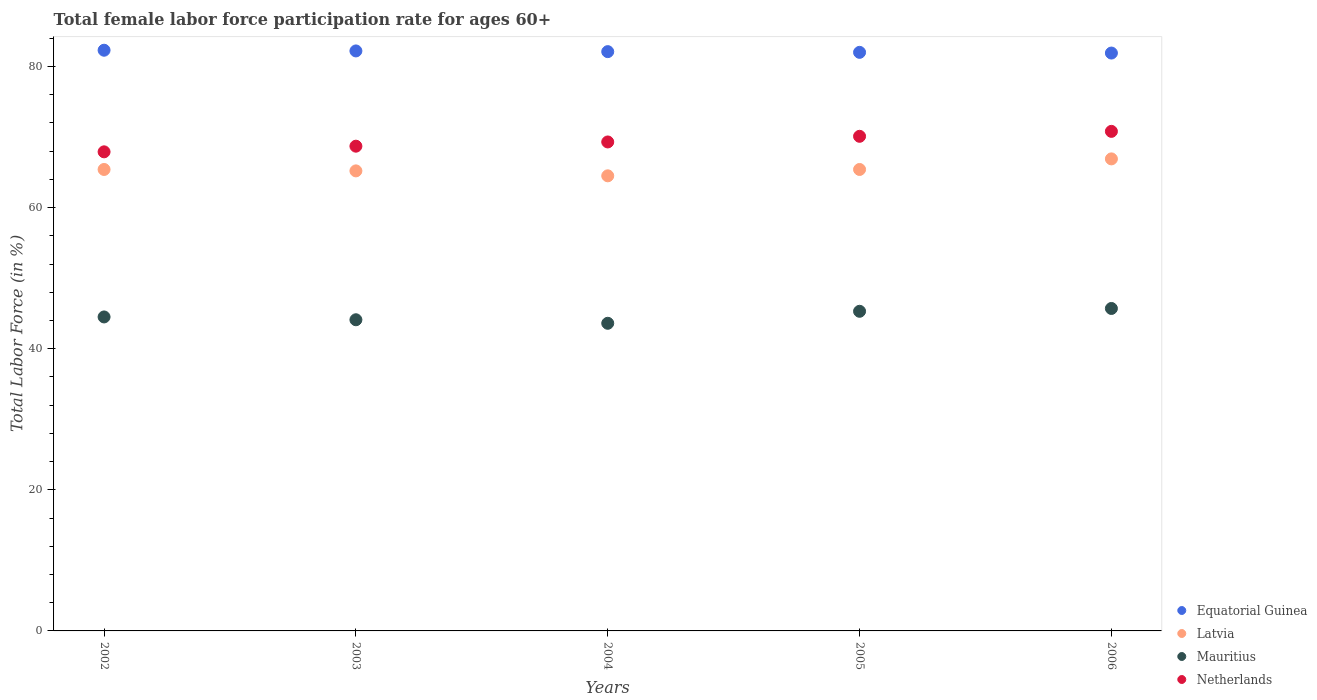How many different coloured dotlines are there?
Offer a terse response. 4. Is the number of dotlines equal to the number of legend labels?
Make the answer very short. Yes. What is the female labor force participation rate in Equatorial Guinea in 2003?
Offer a very short reply. 82.2. Across all years, what is the maximum female labor force participation rate in Netherlands?
Give a very brief answer. 70.8. Across all years, what is the minimum female labor force participation rate in Latvia?
Your response must be concise. 64.5. In which year was the female labor force participation rate in Netherlands maximum?
Keep it short and to the point. 2006. In which year was the female labor force participation rate in Mauritius minimum?
Offer a very short reply. 2004. What is the total female labor force participation rate in Equatorial Guinea in the graph?
Offer a very short reply. 410.5. What is the difference between the female labor force participation rate in Mauritius in 2003 and that in 2006?
Give a very brief answer. -1.6. What is the difference between the female labor force participation rate in Equatorial Guinea in 2003 and the female labor force participation rate in Latvia in 2005?
Your answer should be very brief. 16.8. What is the average female labor force participation rate in Latvia per year?
Offer a very short reply. 65.48. In the year 2003, what is the difference between the female labor force participation rate in Netherlands and female labor force participation rate in Equatorial Guinea?
Make the answer very short. -13.5. What is the ratio of the female labor force participation rate in Netherlands in 2004 to that in 2006?
Ensure brevity in your answer.  0.98. Is the female labor force participation rate in Netherlands in 2002 less than that in 2006?
Your answer should be compact. Yes. What is the difference between the highest and the second highest female labor force participation rate in Equatorial Guinea?
Provide a succinct answer. 0.1. What is the difference between the highest and the lowest female labor force participation rate in Netherlands?
Make the answer very short. 2.9. Is the sum of the female labor force participation rate in Latvia in 2002 and 2004 greater than the maximum female labor force participation rate in Equatorial Guinea across all years?
Your answer should be very brief. Yes. Is it the case that in every year, the sum of the female labor force participation rate in Netherlands and female labor force participation rate in Equatorial Guinea  is greater than the sum of female labor force participation rate in Mauritius and female labor force participation rate in Latvia?
Provide a succinct answer. No. Does the female labor force participation rate in Latvia monotonically increase over the years?
Provide a succinct answer. No. Is the female labor force participation rate in Netherlands strictly greater than the female labor force participation rate in Equatorial Guinea over the years?
Your response must be concise. No. How many years are there in the graph?
Give a very brief answer. 5. Are the values on the major ticks of Y-axis written in scientific E-notation?
Provide a short and direct response. No. Does the graph contain any zero values?
Keep it short and to the point. No. Where does the legend appear in the graph?
Your answer should be compact. Bottom right. What is the title of the graph?
Provide a succinct answer. Total female labor force participation rate for ages 60+. Does "World" appear as one of the legend labels in the graph?
Your answer should be very brief. No. What is the label or title of the Y-axis?
Ensure brevity in your answer.  Total Labor Force (in %). What is the Total Labor Force (in %) in Equatorial Guinea in 2002?
Give a very brief answer. 82.3. What is the Total Labor Force (in %) of Latvia in 2002?
Your response must be concise. 65.4. What is the Total Labor Force (in %) in Mauritius in 2002?
Offer a very short reply. 44.5. What is the Total Labor Force (in %) in Netherlands in 2002?
Ensure brevity in your answer.  67.9. What is the Total Labor Force (in %) in Equatorial Guinea in 2003?
Provide a short and direct response. 82.2. What is the Total Labor Force (in %) of Latvia in 2003?
Ensure brevity in your answer.  65.2. What is the Total Labor Force (in %) of Mauritius in 2003?
Keep it short and to the point. 44.1. What is the Total Labor Force (in %) in Netherlands in 2003?
Offer a terse response. 68.7. What is the Total Labor Force (in %) in Equatorial Guinea in 2004?
Provide a succinct answer. 82.1. What is the Total Labor Force (in %) of Latvia in 2004?
Ensure brevity in your answer.  64.5. What is the Total Labor Force (in %) of Mauritius in 2004?
Provide a succinct answer. 43.6. What is the Total Labor Force (in %) of Netherlands in 2004?
Give a very brief answer. 69.3. What is the Total Labor Force (in %) of Latvia in 2005?
Give a very brief answer. 65.4. What is the Total Labor Force (in %) of Mauritius in 2005?
Ensure brevity in your answer.  45.3. What is the Total Labor Force (in %) of Netherlands in 2005?
Provide a succinct answer. 70.1. What is the Total Labor Force (in %) in Equatorial Guinea in 2006?
Your answer should be compact. 81.9. What is the Total Labor Force (in %) in Latvia in 2006?
Offer a very short reply. 66.9. What is the Total Labor Force (in %) in Mauritius in 2006?
Offer a very short reply. 45.7. What is the Total Labor Force (in %) in Netherlands in 2006?
Make the answer very short. 70.8. Across all years, what is the maximum Total Labor Force (in %) of Equatorial Guinea?
Your answer should be very brief. 82.3. Across all years, what is the maximum Total Labor Force (in %) of Latvia?
Give a very brief answer. 66.9. Across all years, what is the maximum Total Labor Force (in %) in Mauritius?
Give a very brief answer. 45.7. Across all years, what is the maximum Total Labor Force (in %) in Netherlands?
Offer a very short reply. 70.8. Across all years, what is the minimum Total Labor Force (in %) of Equatorial Guinea?
Keep it short and to the point. 81.9. Across all years, what is the minimum Total Labor Force (in %) in Latvia?
Your response must be concise. 64.5. Across all years, what is the minimum Total Labor Force (in %) in Mauritius?
Provide a succinct answer. 43.6. Across all years, what is the minimum Total Labor Force (in %) of Netherlands?
Offer a very short reply. 67.9. What is the total Total Labor Force (in %) in Equatorial Guinea in the graph?
Your response must be concise. 410.5. What is the total Total Labor Force (in %) in Latvia in the graph?
Keep it short and to the point. 327.4. What is the total Total Labor Force (in %) of Mauritius in the graph?
Your response must be concise. 223.2. What is the total Total Labor Force (in %) in Netherlands in the graph?
Offer a very short reply. 346.8. What is the difference between the Total Labor Force (in %) of Latvia in 2002 and that in 2003?
Your answer should be compact. 0.2. What is the difference between the Total Labor Force (in %) of Mauritius in 2002 and that in 2003?
Ensure brevity in your answer.  0.4. What is the difference between the Total Labor Force (in %) of Netherlands in 2002 and that in 2003?
Make the answer very short. -0.8. What is the difference between the Total Labor Force (in %) of Equatorial Guinea in 2002 and that in 2004?
Provide a succinct answer. 0.2. What is the difference between the Total Labor Force (in %) in Latvia in 2002 and that in 2004?
Make the answer very short. 0.9. What is the difference between the Total Labor Force (in %) in Netherlands in 2002 and that in 2004?
Ensure brevity in your answer.  -1.4. What is the difference between the Total Labor Force (in %) of Equatorial Guinea in 2002 and that in 2005?
Provide a short and direct response. 0.3. What is the difference between the Total Labor Force (in %) of Latvia in 2002 and that in 2005?
Make the answer very short. 0. What is the difference between the Total Labor Force (in %) of Netherlands in 2002 and that in 2005?
Offer a terse response. -2.2. What is the difference between the Total Labor Force (in %) of Netherlands in 2002 and that in 2006?
Keep it short and to the point. -2.9. What is the difference between the Total Labor Force (in %) of Latvia in 2003 and that in 2004?
Provide a short and direct response. 0.7. What is the difference between the Total Labor Force (in %) of Mauritius in 2003 and that in 2004?
Give a very brief answer. 0.5. What is the difference between the Total Labor Force (in %) of Netherlands in 2003 and that in 2004?
Provide a succinct answer. -0.6. What is the difference between the Total Labor Force (in %) of Equatorial Guinea in 2003 and that in 2006?
Your answer should be very brief. 0.3. What is the difference between the Total Labor Force (in %) in Mauritius in 2003 and that in 2006?
Make the answer very short. -1.6. What is the difference between the Total Labor Force (in %) in Netherlands in 2003 and that in 2006?
Keep it short and to the point. -2.1. What is the difference between the Total Labor Force (in %) in Latvia in 2004 and that in 2005?
Make the answer very short. -0.9. What is the difference between the Total Labor Force (in %) in Netherlands in 2004 and that in 2005?
Offer a terse response. -0.8. What is the difference between the Total Labor Force (in %) in Equatorial Guinea in 2004 and that in 2006?
Your answer should be compact. 0.2. What is the difference between the Total Labor Force (in %) in Mauritius in 2004 and that in 2006?
Ensure brevity in your answer.  -2.1. What is the difference between the Total Labor Force (in %) in Equatorial Guinea in 2005 and that in 2006?
Provide a short and direct response. 0.1. What is the difference between the Total Labor Force (in %) in Mauritius in 2005 and that in 2006?
Give a very brief answer. -0.4. What is the difference between the Total Labor Force (in %) in Netherlands in 2005 and that in 2006?
Provide a short and direct response. -0.7. What is the difference between the Total Labor Force (in %) in Equatorial Guinea in 2002 and the Total Labor Force (in %) in Latvia in 2003?
Provide a short and direct response. 17.1. What is the difference between the Total Labor Force (in %) of Equatorial Guinea in 2002 and the Total Labor Force (in %) of Mauritius in 2003?
Give a very brief answer. 38.2. What is the difference between the Total Labor Force (in %) in Equatorial Guinea in 2002 and the Total Labor Force (in %) in Netherlands in 2003?
Offer a very short reply. 13.6. What is the difference between the Total Labor Force (in %) of Latvia in 2002 and the Total Labor Force (in %) of Mauritius in 2003?
Ensure brevity in your answer.  21.3. What is the difference between the Total Labor Force (in %) of Latvia in 2002 and the Total Labor Force (in %) of Netherlands in 2003?
Offer a very short reply. -3.3. What is the difference between the Total Labor Force (in %) in Mauritius in 2002 and the Total Labor Force (in %) in Netherlands in 2003?
Your response must be concise. -24.2. What is the difference between the Total Labor Force (in %) of Equatorial Guinea in 2002 and the Total Labor Force (in %) of Latvia in 2004?
Offer a very short reply. 17.8. What is the difference between the Total Labor Force (in %) of Equatorial Guinea in 2002 and the Total Labor Force (in %) of Mauritius in 2004?
Give a very brief answer. 38.7. What is the difference between the Total Labor Force (in %) in Equatorial Guinea in 2002 and the Total Labor Force (in %) in Netherlands in 2004?
Your response must be concise. 13. What is the difference between the Total Labor Force (in %) in Latvia in 2002 and the Total Labor Force (in %) in Mauritius in 2004?
Your answer should be very brief. 21.8. What is the difference between the Total Labor Force (in %) in Mauritius in 2002 and the Total Labor Force (in %) in Netherlands in 2004?
Make the answer very short. -24.8. What is the difference between the Total Labor Force (in %) in Equatorial Guinea in 2002 and the Total Labor Force (in %) in Latvia in 2005?
Provide a succinct answer. 16.9. What is the difference between the Total Labor Force (in %) in Equatorial Guinea in 2002 and the Total Labor Force (in %) in Mauritius in 2005?
Provide a succinct answer. 37. What is the difference between the Total Labor Force (in %) of Equatorial Guinea in 2002 and the Total Labor Force (in %) of Netherlands in 2005?
Offer a terse response. 12.2. What is the difference between the Total Labor Force (in %) of Latvia in 2002 and the Total Labor Force (in %) of Mauritius in 2005?
Your response must be concise. 20.1. What is the difference between the Total Labor Force (in %) of Mauritius in 2002 and the Total Labor Force (in %) of Netherlands in 2005?
Make the answer very short. -25.6. What is the difference between the Total Labor Force (in %) in Equatorial Guinea in 2002 and the Total Labor Force (in %) in Latvia in 2006?
Make the answer very short. 15.4. What is the difference between the Total Labor Force (in %) of Equatorial Guinea in 2002 and the Total Labor Force (in %) of Mauritius in 2006?
Your answer should be compact. 36.6. What is the difference between the Total Labor Force (in %) of Equatorial Guinea in 2002 and the Total Labor Force (in %) of Netherlands in 2006?
Make the answer very short. 11.5. What is the difference between the Total Labor Force (in %) in Latvia in 2002 and the Total Labor Force (in %) in Mauritius in 2006?
Offer a terse response. 19.7. What is the difference between the Total Labor Force (in %) of Latvia in 2002 and the Total Labor Force (in %) of Netherlands in 2006?
Offer a very short reply. -5.4. What is the difference between the Total Labor Force (in %) in Mauritius in 2002 and the Total Labor Force (in %) in Netherlands in 2006?
Make the answer very short. -26.3. What is the difference between the Total Labor Force (in %) in Equatorial Guinea in 2003 and the Total Labor Force (in %) in Latvia in 2004?
Ensure brevity in your answer.  17.7. What is the difference between the Total Labor Force (in %) in Equatorial Guinea in 2003 and the Total Labor Force (in %) in Mauritius in 2004?
Make the answer very short. 38.6. What is the difference between the Total Labor Force (in %) in Equatorial Guinea in 2003 and the Total Labor Force (in %) in Netherlands in 2004?
Make the answer very short. 12.9. What is the difference between the Total Labor Force (in %) in Latvia in 2003 and the Total Labor Force (in %) in Mauritius in 2004?
Provide a succinct answer. 21.6. What is the difference between the Total Labor Force (in %) in Latvia in 2003 and the Total Labor Force (in %) in Netherlands in 2004?
Keep it short and to the point. -4.1. What is the difference between the Total Labor Force (in %) in Mauritius in 2003 and the Total Labor Force (in %) in Netherlands in 2004?
Your response must be concise. -25.2. What is the difference between the Total Labor Force (in %) of Equatorial Guinea in 2003 and the Total Labor Force (in %) of Latvia in 2005?
Provide a succinct answer. 16.8. What is the difference between the Total Labor Force (in %) in Equatorial Guinea in 2003 and the Total Labor Force (in %) in Mauritius in 2005?
Keep it short and to the point. 36.9. What is the difference between the Total Labor Force (in %) of Equatorial Guinea in 2003 and the Total Labor Force (in %) of Netherlands in 2005?
Your answer should be very brief. 12.1. What is the difference between the Total Labor Force (in %) in Latvia in 2003 and the Total Labor Force (in %) in Mauritius in 2005?
Offer a terse response. 19.9. What is the difference between the Total Labor Force (in %) in Mauritius in 2003 and the Total Labor Force (in %) in Netherlands in 2005?
Make the answer very short. -26. What is the difference between the Total Labor Force (in %) in Equatorial Guinea in 2003 and the Total Labor Force (in %) in Mauritius in 2006?
Provide a succinct answer. 36.5. What is the difference between the Total Labor Force (in %) of Equatorial Guinea in 2003 and the Total Labor Force (in %) of Netherlands in 2006?
Offer a very short reply. 11.4. What is the difference between the Total Labor Force (in %) of Latvia in 2003 and the Total Labor Force (in %) of Mauritius in 2006?
Keep it short and to the point. 19.5. What is the difference between the Total Labor Force (in %) of Latvia in 2003 and the Total Labor Force (in %) of Netherlands in 2006?
Offer a terse response. -5.6. What is the difference between the Total Labor Force (in %) of Mauritius in 2003 and the Total Labor Force (in %) of Netherlands in 2006?
Your response must be concise. -26.7. What is the difference between the Total Labor Force (in %) of Equatorial Guinea in 2004 and the Total Labor Force (in %) of Latvia in 2005?
Keep it short and to the point. 16.7. What is the difference between the Total Labor Force (in %) in Equatorial Guinea in 2004 and the Total Labor Force (in %) in Mauritius in 2005?
Ensure brevity in your answer.  36.8. What is the difference between the Total Labor Force (in %) in Mauritius in 2004 and the Total Labor Force (in %) in Netherlands in 2005?
Your response must be concise. -26.5. What is the difference between the Total Labor Force (in %) in Equatorial Guinea in 2004 and the Total Labor Force (in %) in Latvia in 2006?
Give a very brief answer. 15.2. What is the difference between the Total Labor Force (in %) in Equatorial Guinea in 2004 and the Total Labor Force (in %) in Mauritius in 2006?
Make the answer very short. 36.4. What is the difference between the Total Labor Force (in %) of Latvia in 2004 and the Total Labor Force (in %) of Netherlands in 2006?
Your answer should be very brief. -6.3. What is the difference between the Total Labor Force (in %) of Mauritius in 2004 and the Total Labor Force (in %) of Netherlands in 2006?
Make the answer very short. -27.2. What is the difference between the Total Labor Force (in %) in Equatorial Guinea in 2005 and the Total Labor Force (in %) in Mauritius in 2006?
Offer a terse response. 36.3. What is the difference between the Total Labor Force (in %) of Mauritius in 2005 and the Total Labor Force (in %) of Netherlands in 2006?
Provide a short and direct response. -25.5. What is the average Total Labor Force (in %) in Equatorial Guinea per year?
Give a very brief answer. 82.1. What is the average Total Labor Force (in %) of Latvia per year?
Ensure brevity in your answer.  65.48. What is the average Total Labor Force (in %) in Mauritius per year?
Offer a very short reply. 44.64. What is the average Total Labor Force (in %) in Netherlands per year?
Provide a short and direct response. 69.36. In the year 2002, what is the difference between the Total Labor Force (in %) of Equatorial Guinea and Total Labor Force (in %) of Mauritius?
Your answer should be compact. 37.8. In the year 2002, what is the difference between the Total Labor Force (in %) in Equatorial Guinea and Total Labor Force (in %) in Netherlands?
Make the answer very short. 14.4. In the year 2002, what is the difference between the Total Labor Force (in %) of Latvia and Total Labor Force (in %) of Mauritius?
Your response must be concise. 20.9. In the year 2002, what is the difference between the Total Labor Force (in %) in Mauritius and Total Labor Force (in %) in Netherlands?
Give a very brief answer. -23.4. In the year 2003, what is the difference between the Total Labor Force (in %) in Equatorial Guinea and Total Labor Force (in %) in Latvia?
Offer a very short reply. 17. In the year 2003, what is the difference between the Total Labor Force (in %) of Equatorial Guinea and Total Labor Force (in %) of Mauritius?
Ensure brevity in your answer.  38.1. In the year 2003, what is the difference between the Total Labor Force (in %) in Equatorial Guinea and Total Labor Force (in %) in Netherlands?
Ensure brevity in your answer.  13.5. In the year 2003, what is the difference between the Total Labor Force (in %) of Latvia and Total Labor Force (in %) of Mauritius?
Offer a terse response. 21.1. In the year 2003, what is the difference between the Total Labor Force (in %) of Mauritius and Total Labor Force (in %) of Netherlands?
Ensure brevity in your answer.  -24.6. In the year 2004, what is the difference between the Total Labor Force (in %) in Equatorial Guinea and Total Labor Force (in %) in Mauritius?
Provide a short and direct response. 38.5. In the year 2004, what is the difference between the Total Labor Force (in %) in Equatorial Guinea and Total Labor Force (in %) in Netherlands?
Give a very brief answer. 12.8. In the year 2004, what is the difference between the Total Labor Force (in %) in Latvia and Total Labor Force (in %) in Mauritius?
Ensure brevity in your answer.  20.9. In the year 2004, what is the difference between the Total Labor Force (in %) of Mauritius and Total Labor Force (in %) of Netherlands?
Ensure brevity in your answer.  -25.7. In the year 2005, what is the difference between the Total Labor Force (in %) of Equatorial Guinea and Total Labor Force (in %) of Mauritius?
Your answer should be compact. 36.7. In the year 2005, what is the difference between the Total Labor Force (in %) in Equatorial Guinea and Total Labor Force (in %) in Netherlands?
Keep it short and to the point. 11.9. In the year 2005, what is the difference between the Total Labor Force (in %) in Latvia and Total Labor Force (in %) in Mauritius?
Make the answer very short. 20.1. In the year 2005, what is the difference between the Total Labor Force (in %) in Latvia and Total Labor Force (in %) in Netherlands?
Keep it short and to the point. -4.7. In the year 2005, what is the difference between the Total Labor Force (in %) in Mauritius and Total Labor Force (in %) in Netherlands?
Make the answer very short. -24.8. In the year 2006, what is the difference between the Total Labor Force (in %) in Equatorial Guinea and Total Labor Force (in %) in Mauritius?
Your answer should be compact. 36.2. In the year 2006, what is the difference between the Total Labor Force (in %) in Latvia and Total Labor Force (in %) in Mauritius?
Provide a succinct answer. 21.2. In the year 2006, what is the difference between the Total Labor Force (in %) of Latvia and Total Labor Force (in %) of Netherlands?
Offer a terse response. -3.9. In the year 2006, what is the difference between the Total Labor Force (in %) in Mauritius and Total Labor Force (in %) in Netherlands?
Make the answer very short. -25.1. What is the ratio of the Total Labor Force (in %) of Latvia in 2002 to that in 2003?
Your response must be concise. 1. What is the ratio of the Total Labor Force (in %) of Mauritius in 2002 to that in 2003?
Ensure brevity in your answer.  1.01. What is the ratio of the Total Labor Force (in %) in Netherlands in 2002 to that in 2003?
Your answer should be very brief. 0.99. What is the ratio of the Total Labor Force (in %) in Mauritius in 2002 to that in 2004?
Offer a terse response. 1.02. What is the ratio of the Total Labor Force (in %) of Netherlands in 2002 to that in 2004?
Your answer should be compact. 0.98. What is the ratio of the Total Labor Force (in %) of Equatorial Guinea in 2002 to that in 2005?
Your response must be concise. 1. What is the ratio of the Total Labor Force (in %) of Latvia in 2002 to that in 2005?
Make the answer very short. 1. What is the ratio of the Total Labor Force (in %) in Mauritius in 2002 to that in 2005?
Offer a terse response. 0.98. What is the ratio of the Total Labor Force (in %) of Netherlands in 2002 to that in 2005?
Your answer should be compact. 0.97. What is the ratio of the Total Labor Force (in %) of Equatorial Guinea in 2002 to that in 2006?
Keep it short and to the point. 1. What is the ratio of the Total Labor Force (in %) in Latvia in 2002 to that in 2006?
Make the answer very short. 0.98. What is the ratio of the Total Labor Force (in %) of Mauritius in 2002 to that in 2006?
Offer a very short reply. 0.97. What is the ratio of the Total Labor Force (in %) in Netherlands in 2002 to that in 2006?
Your answer should be very brief. 0.96. What is the ratio of the Total Labor Force (in %) in Equatorial Guinea in 2003 to that in 2004?
Give a very brief answer. 1. What is the ratio of the Total Labor Force (in %) of Latvia in 2003 to that in 2004?
Make the answer very short. 1.01. What is the ratio of the Total Labor Force (in %) of Mauritius in 2003 to that in 2004?
Your answer should be very brief. 1.01. What is the ratio of the Total Labor Force (in %) in Equatorial Guinea in 2003 to that in 2005?
Your answer should be very brief. 1. What is the ratio of the Total Labor Force (in %) in Mauritius in 2003 to that in 2005?
Provide a short and direct response. 0.97. What is the ratio of the Total Labor Force (in %) in Netherlands in 2003 to that in 2005?
Your response must be concise. 0.98. What is the ratio of the Total Labor Force (in %) of Latvia in 2003 to that in 2006?
Make the answer very short. 0.97. What is the ratio of the Total Labor Force (in %) in Netherlands in 2003 to that in 2006?
Make the answer very short. 0.97. What is the ratio of the Total Labor Force (in %) in Latvia in 2004 to that in 2005?
Provide a succinct answer. 0.99. What is the ratio of the Total Labor Force (in %) in Mauritius in 2004 to that in 2005?
Offer a terse response. 0.96. What is the ratio of the Total Labor Force (in %) of Netherlands in 2004 to that in 2005?
Provide a succinct answer. 0.99. What is the ratio of the Total Labor Force (in %) of Latvia in 2004 to that in 2006?
Your response must be concise. 0.96. What is the ratio of the Total Labor Force (in %) of Mauritius in 2004 to that in 2006?
Provide a short and direct response. 0.95. What is the ratio of the Total Labor Force (in %) in Netherlands in 2004 to that in 2006?
Keep it short and to the point. 0.98. What is the ratio of the Total Labor Force (in %) of Equatorial Guinea in 2005 to that in 2006?
Offer a terse response. 1. What is the ratio of the Total Labor Force (in %) in Latvia in 2005 to that in 2006?
Provide a short and direct response. 0.98. What is the ratio of the Total Labor Force (in %) in Mauritius in 2005 to that in 2006?
Offer a very short reply. 0.99. What is the ratio of the Total Labor Force (in %) in Netherlands in 2005 to that in 2006?
Your response must be concise. 0.99. What is the difference between the highest and the second highest Total Labor Force (in %) of Equatorial Guinea?
Ensure brevity in your answer.  0.1. What is the difference between the highest and the second highest Total Labor Force (in %) in Netherlands?
Offer a terse response. 0.7. What is the difference between the highest and the lowest Total Labor Force (in %) in Latvia?
Your response must be concise. 2.4. 